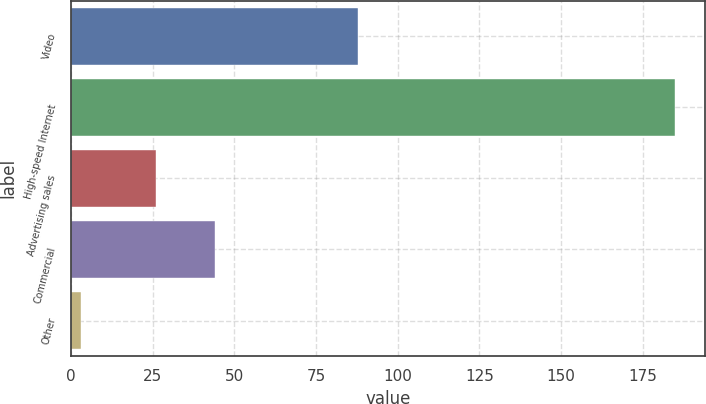<chart> <loc_0><loc_0><loc_500><loc_500><bar_chart><fcel>Video<fcel>High-speed Internet<fcel>Advertising sales<fcel>Commercial<fcel>Other<nl><fcel>88<fcel>185<fcel>26<fcel>44.2<fcel>3<nl></chart> 